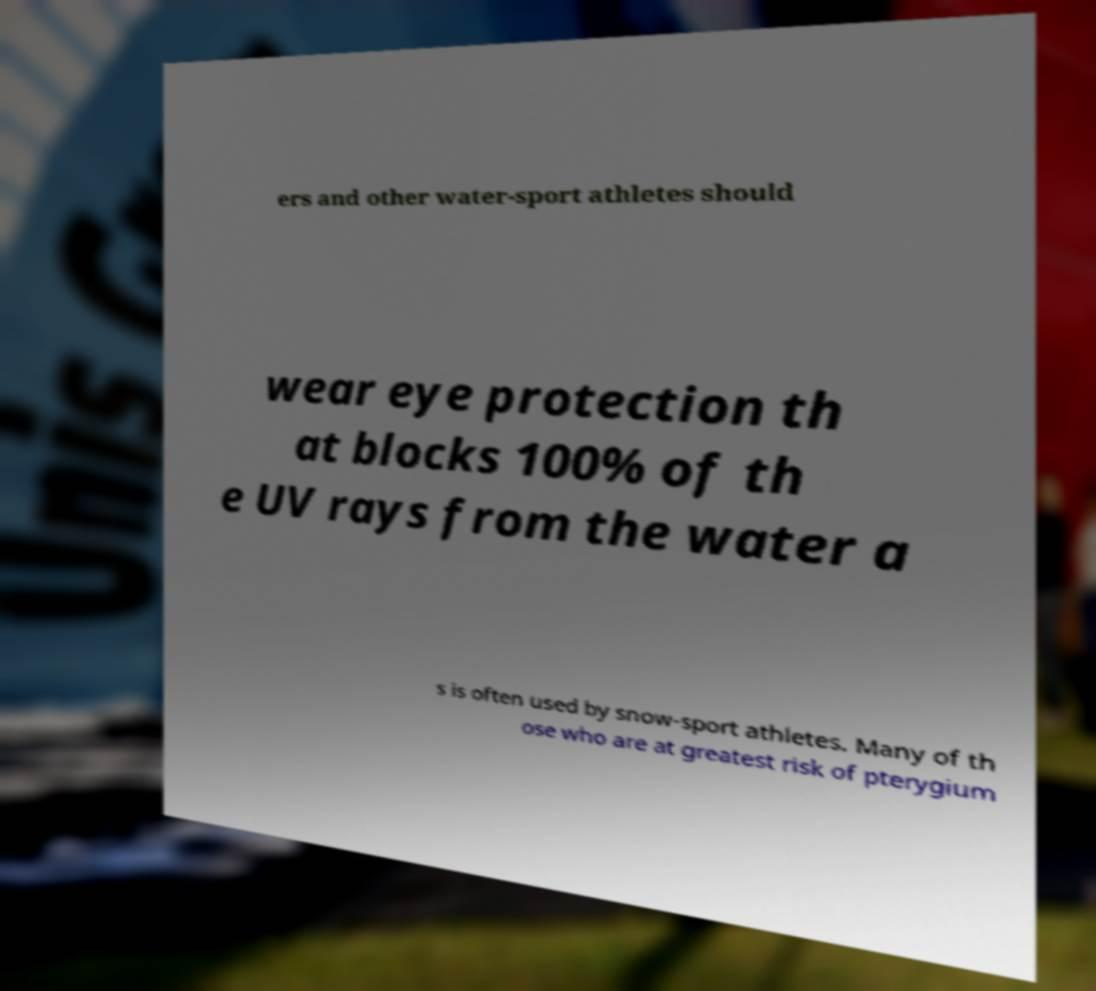Can you read and provide the text displayed in the image?This photo seems to have some interesting text. Can you extract and type it out for me? ers and other water-sport athletes should wear eye protection th at blocks 100% of th e UV rays from the water a s is often used by snow-sport athletes. Many of th ose who are at greatest risk of pterygium 